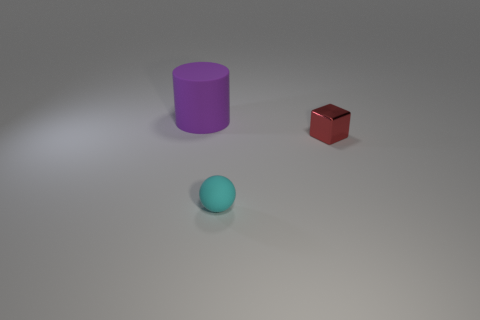Add 2 big purple matte cylinders. How many objects exist? 5 Subtract 1 cubes. How many cubes are left? 0 Subtract all spheres. How many objects are left? 2 Subtract all cyan matte things. Subtract all small cyan matte objects. How many objects are left? 1 Add 2 tiny metal things. How many tiny metal things are left? 3 Add 2 small cyan matte spheres. How many small cyan matte spheres exist? 3 Subtract 0 green spheres. How many objects are left? 3 Subtract all red cylinders. Subtract all gray balls. How many cylinders are left? 1 Subtract all gray cylinders. How many brown balls are left? 0 